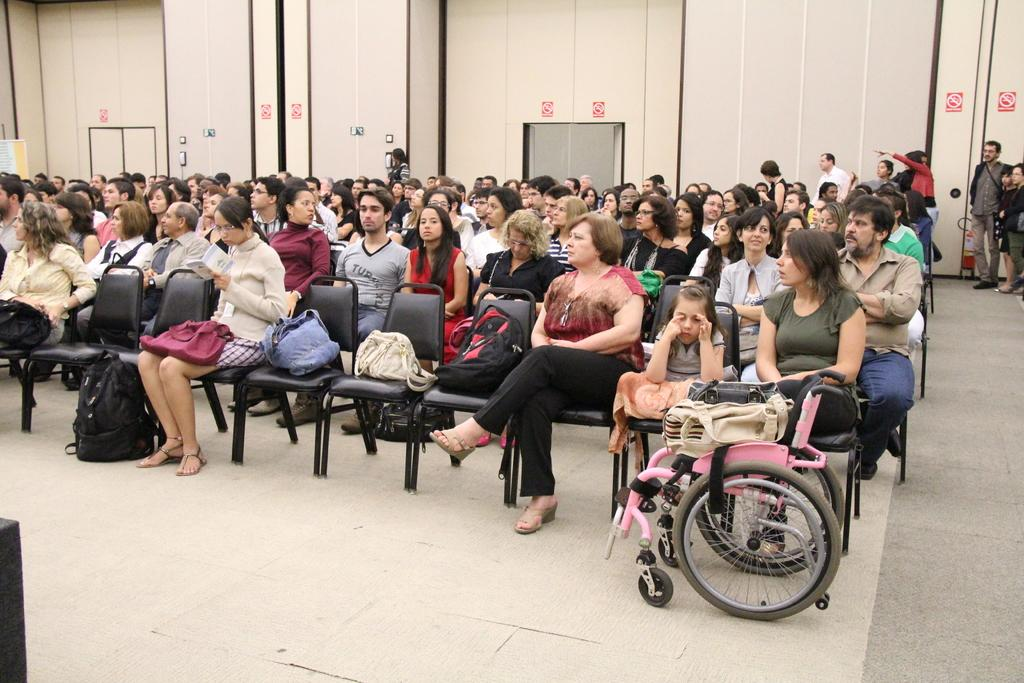How many people are in the image? There are a lot of people in the image. What are the people doing in the image? The people are sitting on chairs. What is the name of the person sitting in the front row? The provided facts do not mention any names, so it is not possible to answer that question. 